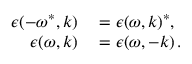<formula> <loc_0><loc_0><loc_500><loc_500>\begin{array} { r l } { \epsilon ( - \omega ^ { * } , k ) } & = \epsilon ( \omega , k ) ^ { * } , } \\ { \epsilon ( \omega , k ) } & = \epsilon ( \omega , - k ) \, . } \end{array}</formula> 